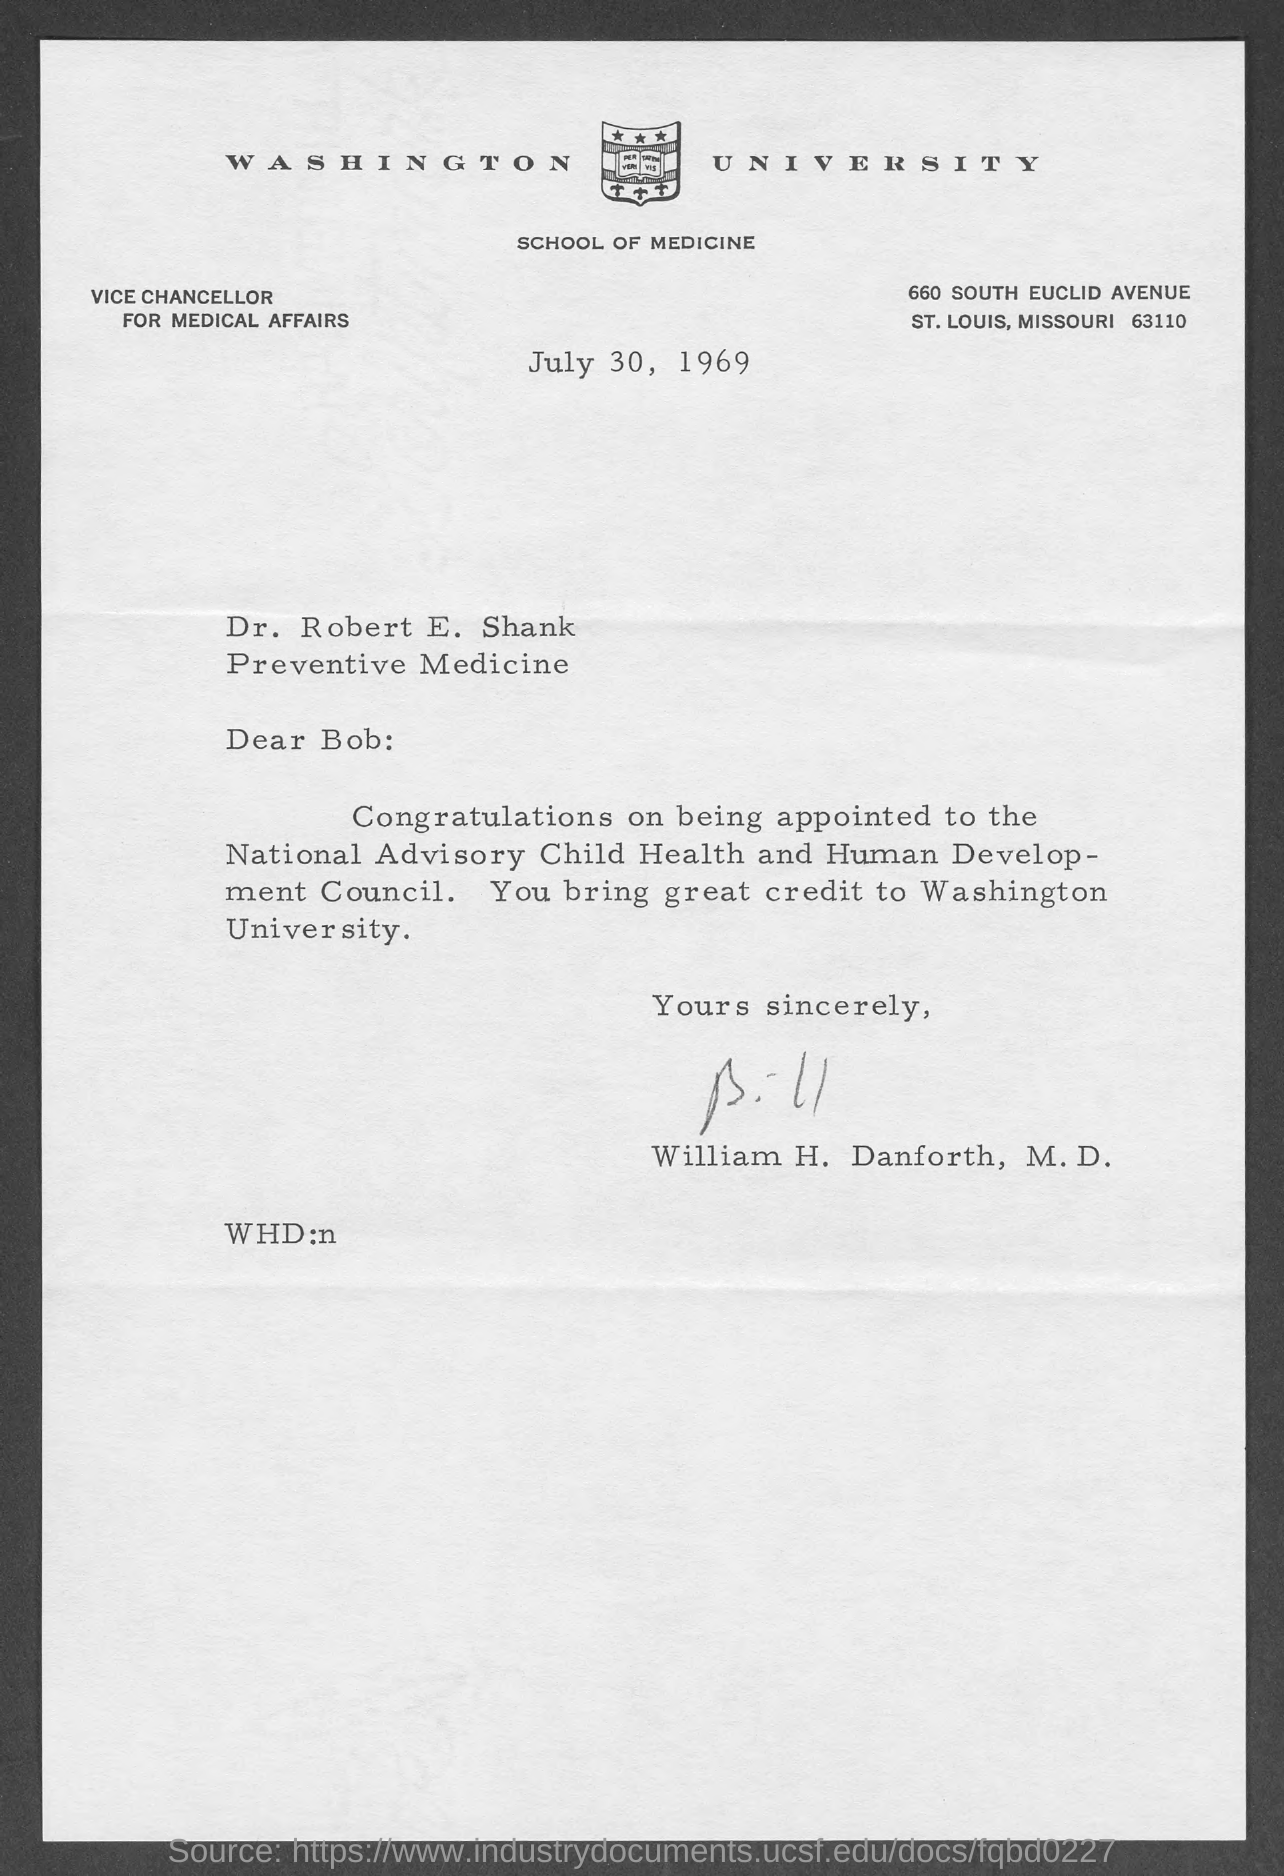Specify some key components in this picture. This letter is written by William H. Danforth, M.D. The name of the university is Washington University. The date mentioned is July 30, 1969. 